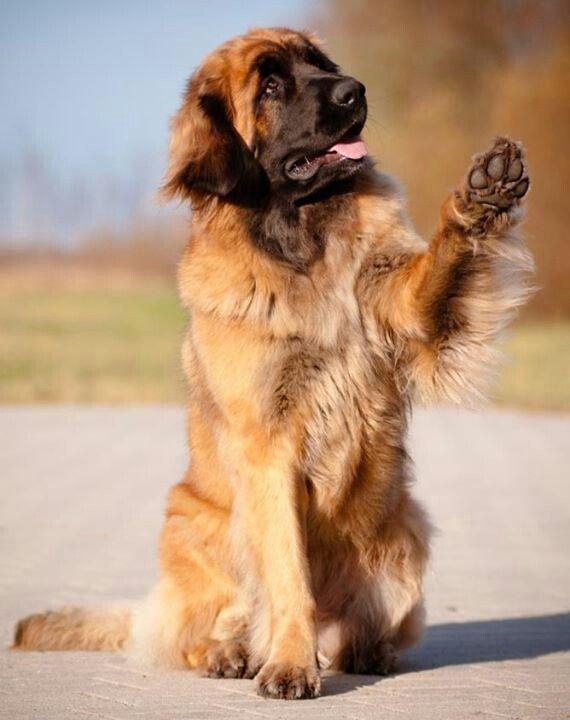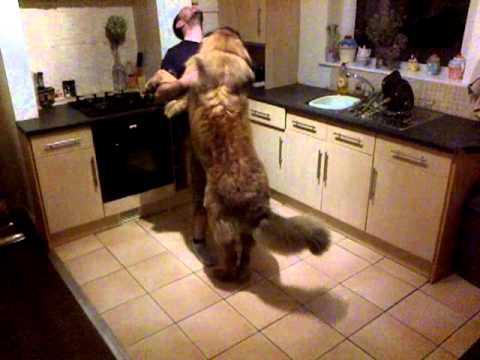The first image is the image on the left, the second image is the image on the right. Given the left and right images, does the statement "A person stands face-to-face with arms around a big standing dog." hold true? Answer yes or no. Yes. The first image is the image on the left, the second image is the image on the right. Analyze the images presented: Is the assertion "A dog is hugging a human in one of the images." valid? Answer yes or no. Yes. 